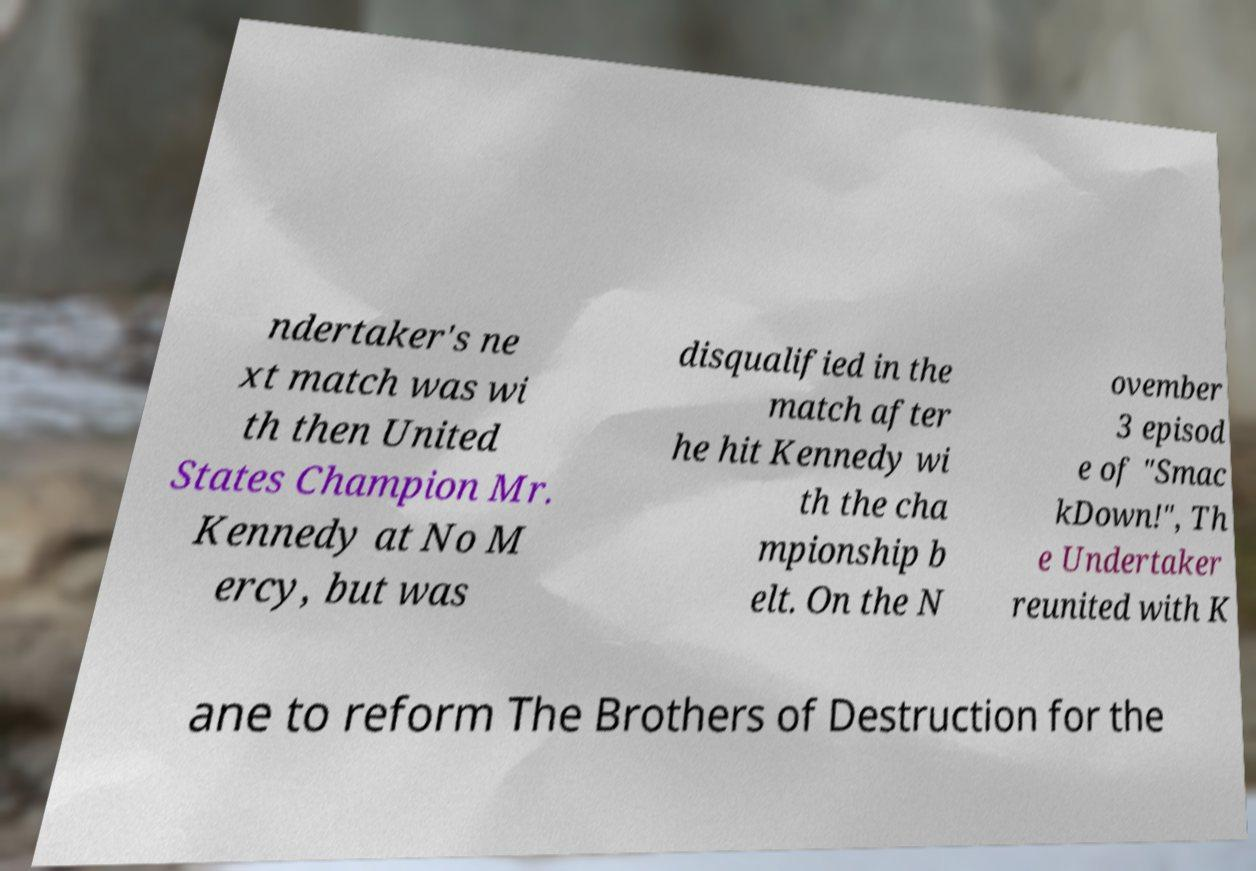Can you read and provide the text displayed in the image?This photo seems to have some interesting text. Can you extract and type it out for me? ndertaker's ne xt match was wi th then United States Champion Mr. Kennedy at No M ercy, but was disqualified in the match after he hit Kennedy wi th the cha mpionship b elt. On the N ovember 3 episod e of "Smac kDown!", Th e Undertaker reunited with K ane to reform The Brothers of Destruction for the 